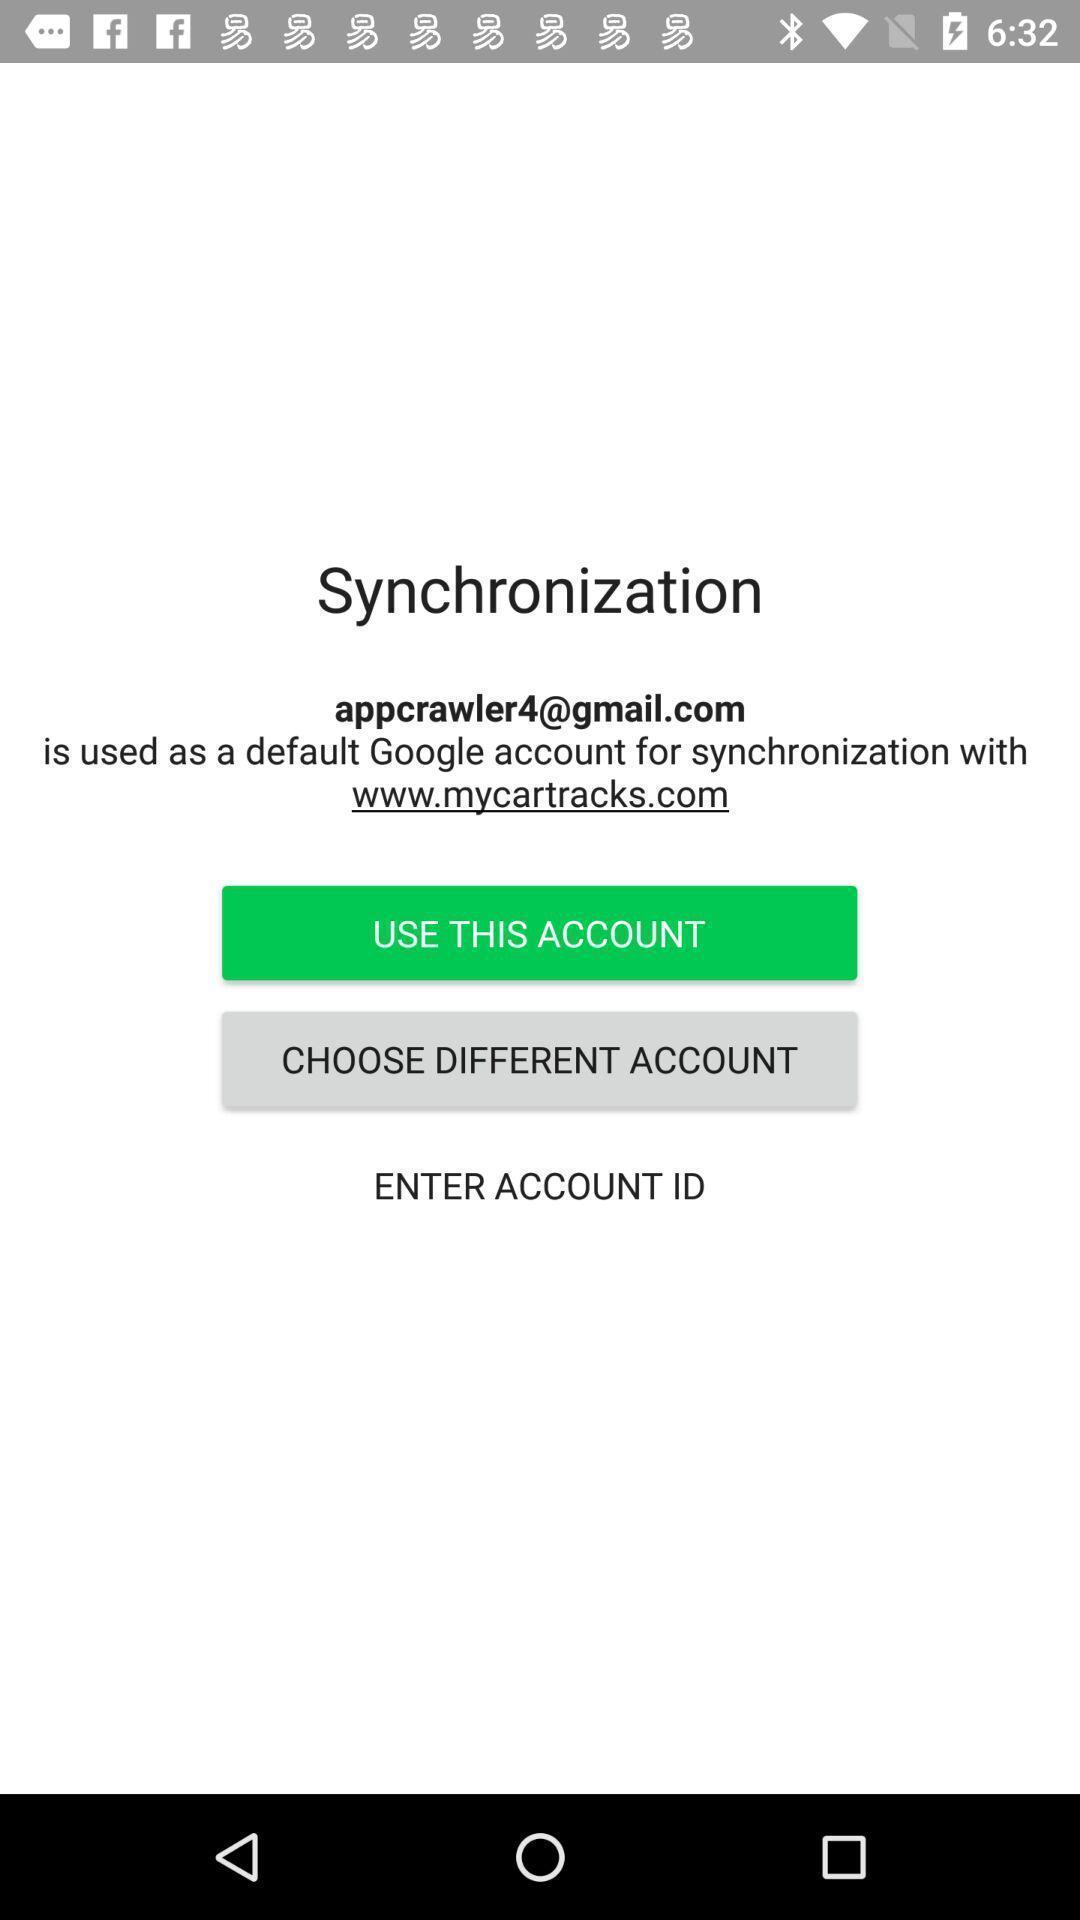Provide a description of this screenshot. Screen displaying the login page. 